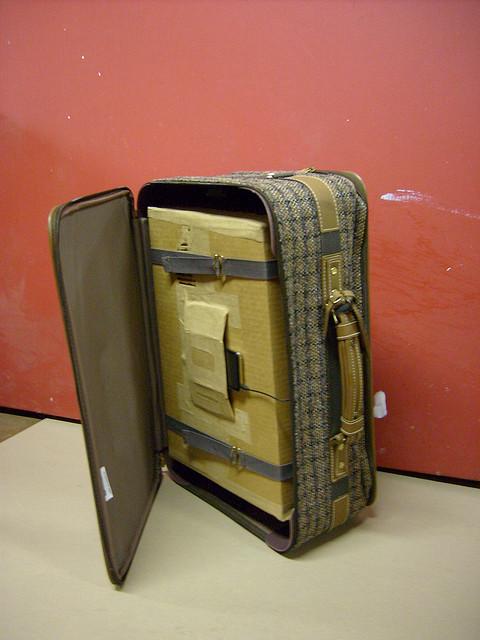Is this a kitchen appliance?
Concise answer only. No. Is the wall red?
Give a very brief answer. Yes. What's inside the suitcase?
Short answer required. Box. Is this a suitcase?
Give a very brief answer. Yes. 